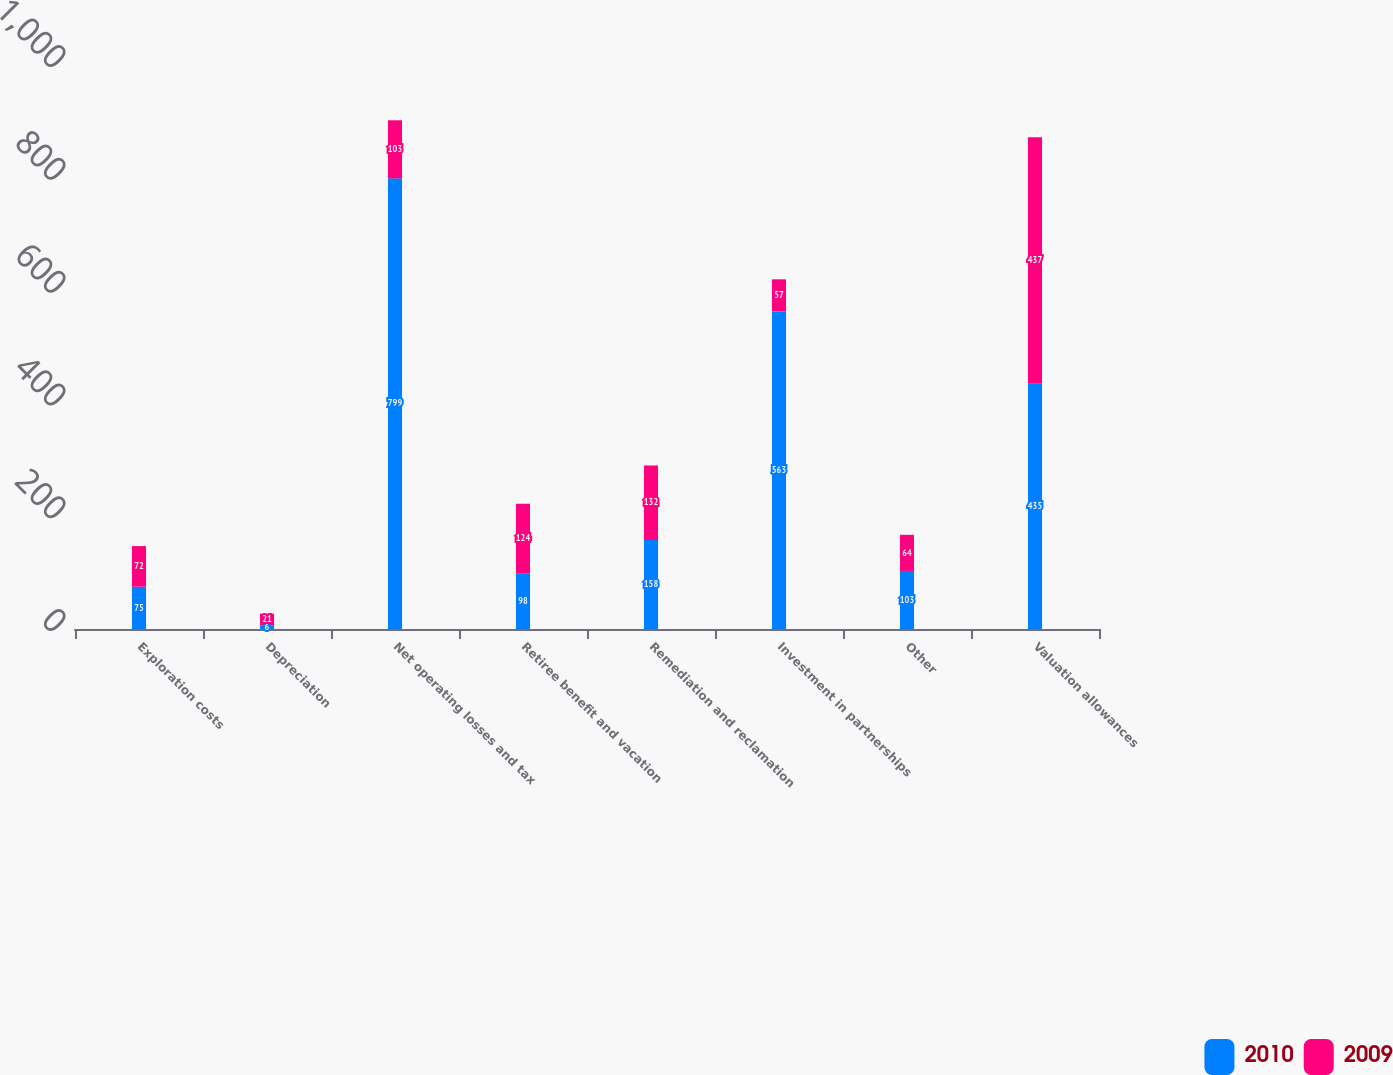Convert chart. <chart><loc_0><loc_0><loc_500><loc_500><stacked_bar_chart><ecel><fcel>Exploration costs<fcel>Depreciation<fcel>Net operating losses and tax<fcel>Retiree benefit and vacation<fcel>Remediation and reclamation<fcel>Investment in partnerships<fcel>Other<fcel>Valuation allowances<nl><fcel>2010<fcel>75<fcel>6<fcel>799<fcel>98<fcel>158<fcel>563<fcel>103<fcel>435<nl><fcel>2009<fcel>72<fcel>21<fcel>103<fcel>124<fcel>132<fcel>57<fcel>64<fcel>437<nl></chart> 